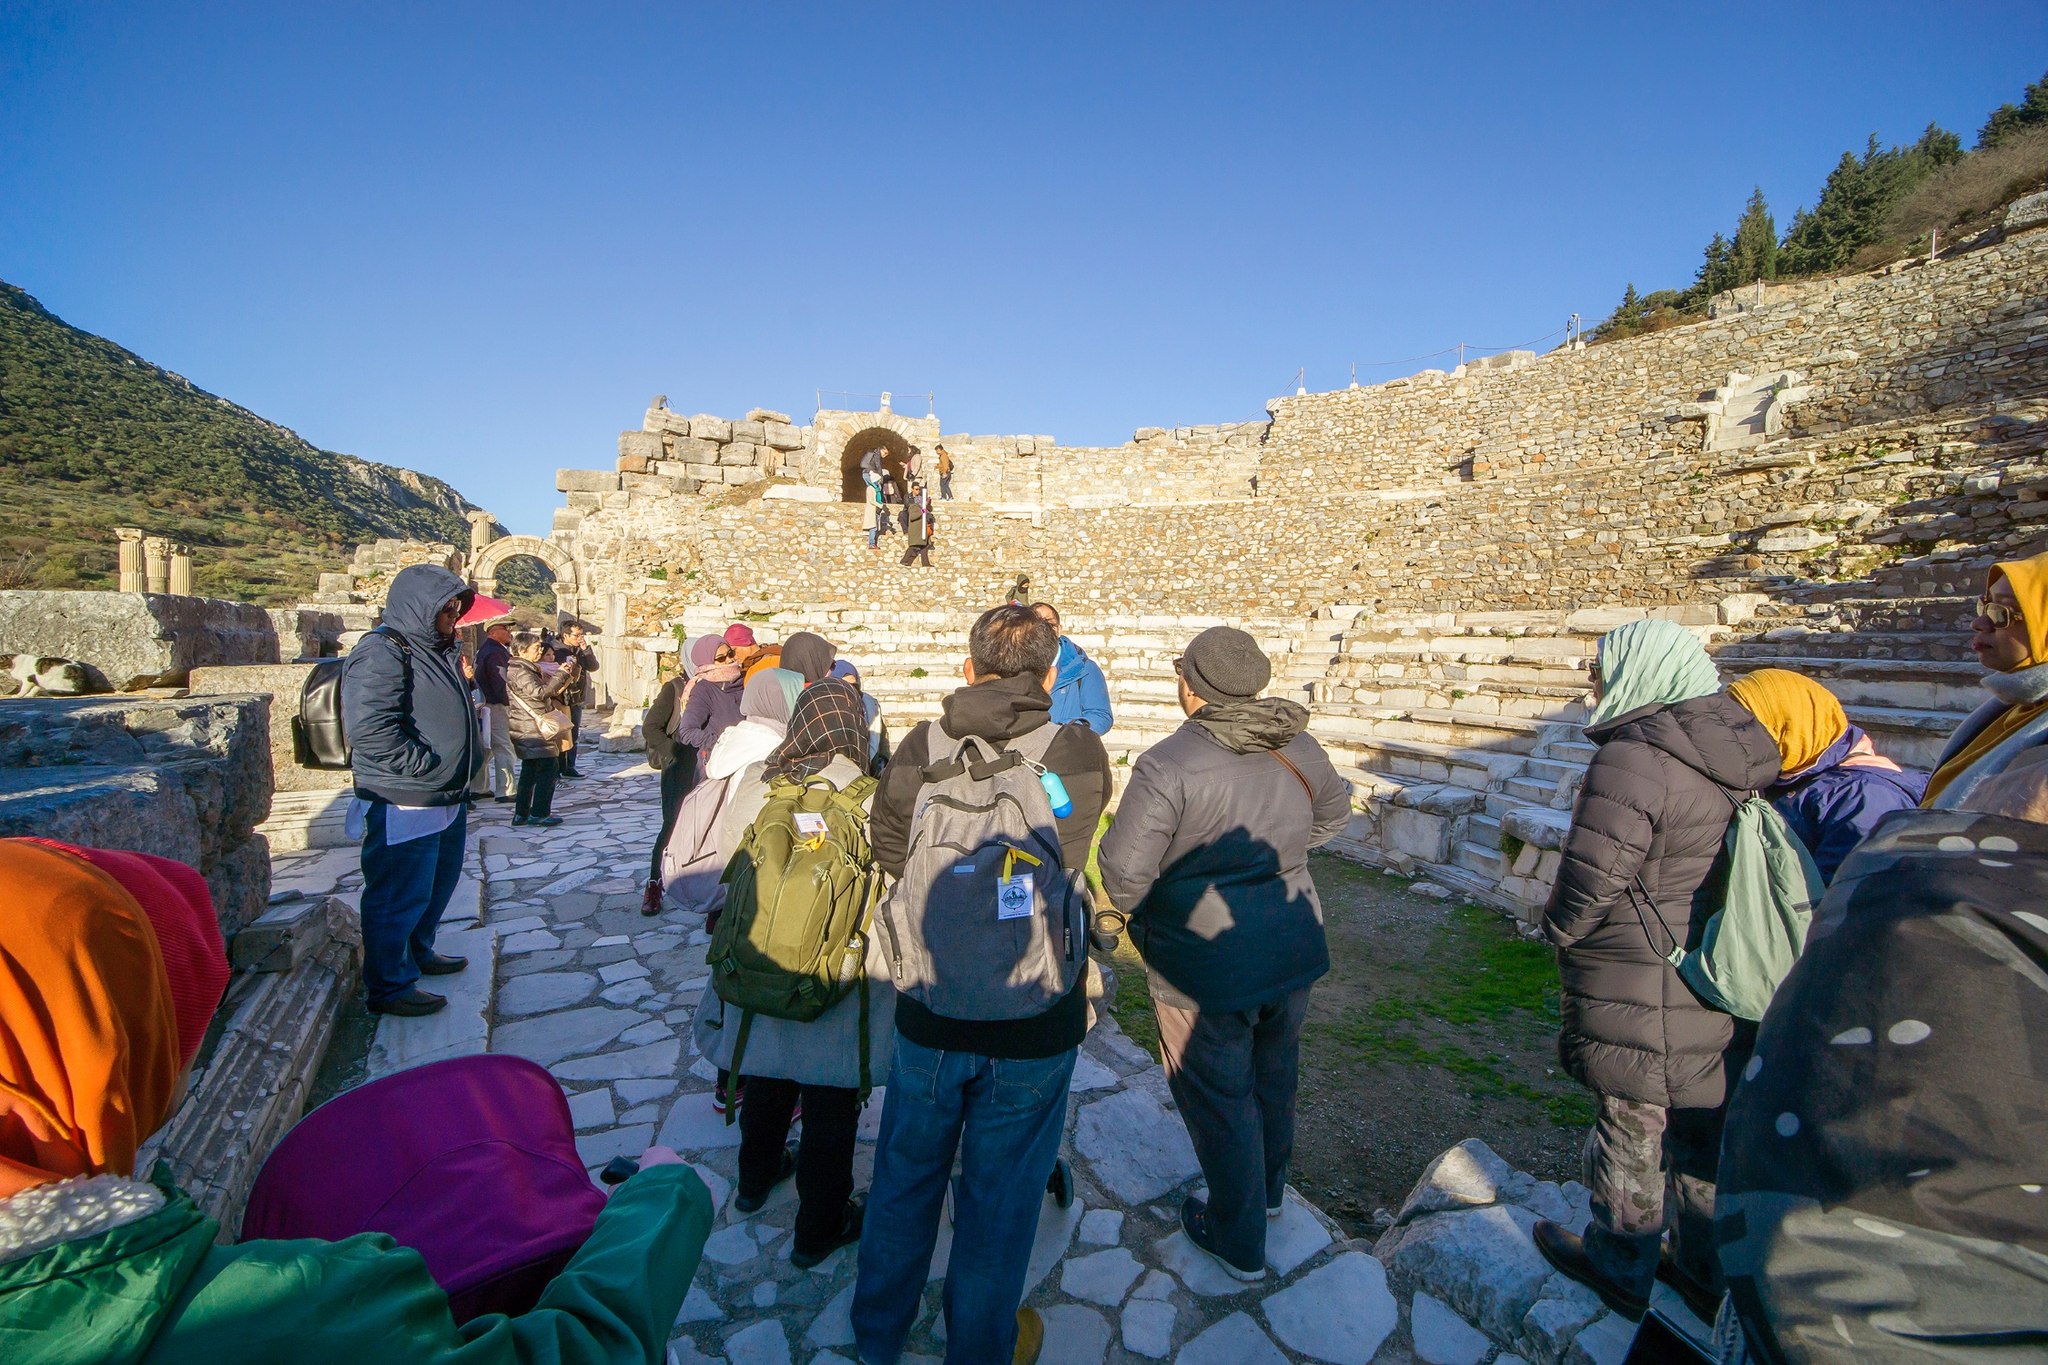What can you infer about the weather and the time of year in this image? The weather in the image appears to be clear and sunny, as indicated by the bright, blue sky and the distinct shadows cast by the tourists and structures. The tourists are dressed in jackets, hats, and warm clothing, suggesting that it might be a slightly cool day, likely in late autumn or early spring when temperatures can be brisk despite the sunshine. Describe a short adventure that these tourists might experience here. The tourists start their adventure by gathering near the stone pathway, where a knowledgeable guide begins to recount the history of the ruins. As they move through the site, they ascend the ancient stone steps, pausing at the archway to take in the view of the amphitheater below. Each step brings new discoveries, from inscriptions on the walls to remnants of ancient artifacts. The adventure culminates with a breathtaking view from the top, where the serene landscape of mountains and scattered trees stretches before them, offering a moment of reflection and awe at the vastness of history laid out at their feet. 